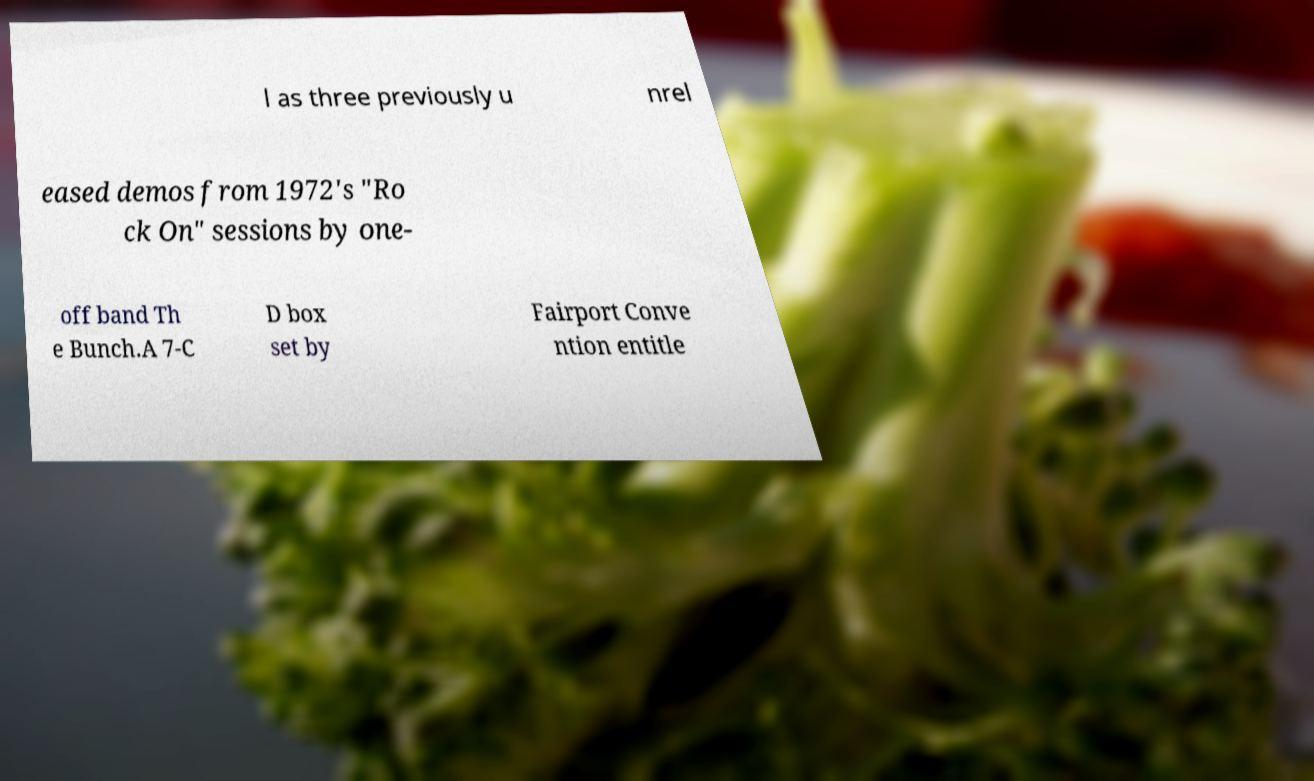Could you assist in decoding the text presented in this image and type it out clearly? l as three previously u nrel eased demos from 1972's "Ro ck On" sessions by one- off band Th e Bunch.A 7-C D box set by Fairport Conve ntion entitle 